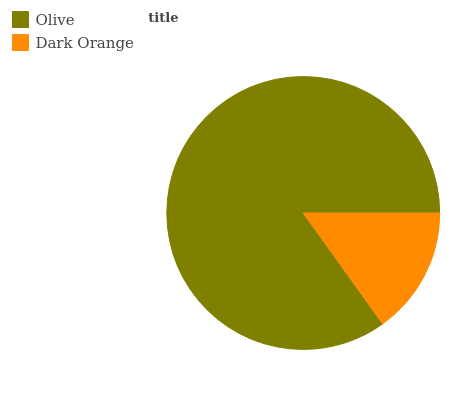Is Dark Orange the minimum?
Answer yes or no. Yes. Is Olive the maximum?
Answer yes or no. Yes. Is Dark Orange the maximum?
Answer yes or no. No. Is Olive greater than Dark Orange?
Answer yes or no. Yes. Is Dark Orange less than Olive?
Answer yes or no. Yes. Is Dark Orange greater than Olive?
Answer yes or no. No. Is Olive less than Dark Orange?
Answer yes or no. No. Is Olive the high median?
Answer yes or no. Yes. Is Dark Orange the low median?
Answer yes or no. Yes. Is Dark Orange the high median?
Answer yes or no. No. Is Olive the low median?
Answer yes or no. No. 